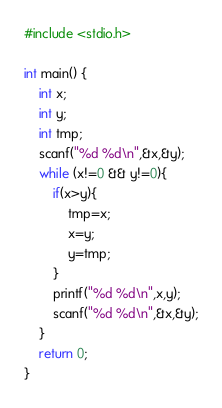Convert code to text. <code><loc_0><loc_0><loc_500><loc_500><_C_>#include <stdio.h>

int main() {
    int x;
    int y;
    int tmp;
    scanf("%d %d\n",&x,&y);
    while (x!=0 && y!=0){
        if(x>y){
            tmp=x;
            x=y;
            y=tmp;
        }
        printf("%d %d\n",x,y);
        scanf("%d %d\n",&x,&y);
    }
    return 0;
}</code> 